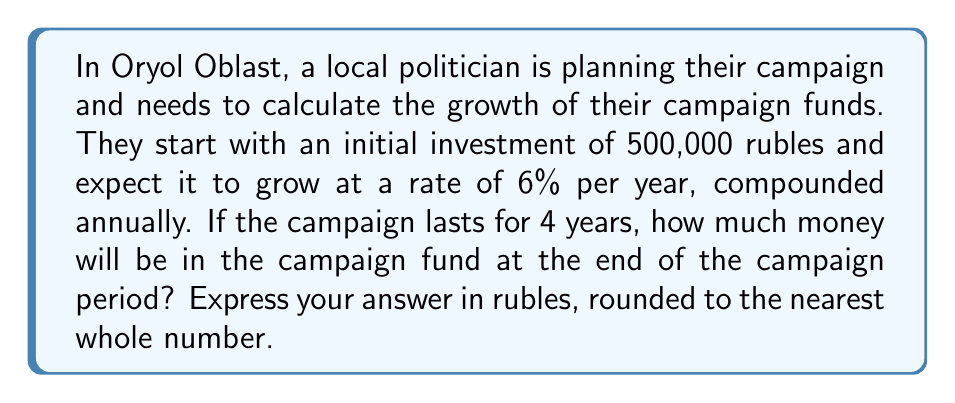What is the answer to this math problem? To solve this problem, we'll use the compound interest formula:

$$ A = P(1 + r)^t $$

Where:
$A$ = final amount
$P$ = principal (initial investment)
$r$ = annual interest rate (as a decimal)
$t$ = time in years

Given:
$P = 500,000$ rubles
$r = 0.06$ (6% expressed as a decimal)
$t = 4$ years

Let's substitute these values into the formula:

$$ A = 500,000(1 + 0.06)^4 $$

Now, let's calculate step by step:

1) First, calculate $(1 + 0.06)^4$:
   $$ (1.06)^4 = 1.26247696 $$

2) Multiply this by the initial investment:
   $$ 500,000 \times 1.26247696 = 631,238.48 $$

3) Round to the nearest whole number:
   $$ 631,238 \text{ rubles} $$
Answer: 631,238 rubles 